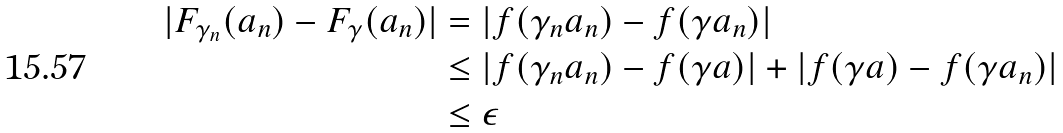Convert formula to latex. <formula><loc_0><loc_0><loc_500><loc_500>| F _ { \gamma _ { n } } ( a _ { n } ) - F _ { \gamma } ( a _ { n } ) | & = | f ( \gamma _ { n } a _ { n } ) - f ( \gamma a _ { n } ) | \\ & \leq | f ( \gamma _ { n } a _ { n } ) - f ( \gamma a ) | + | f ( \gamma a ) - f ( \gamma a _ { n } ) | \\ & \leq \epsilon</formula> 